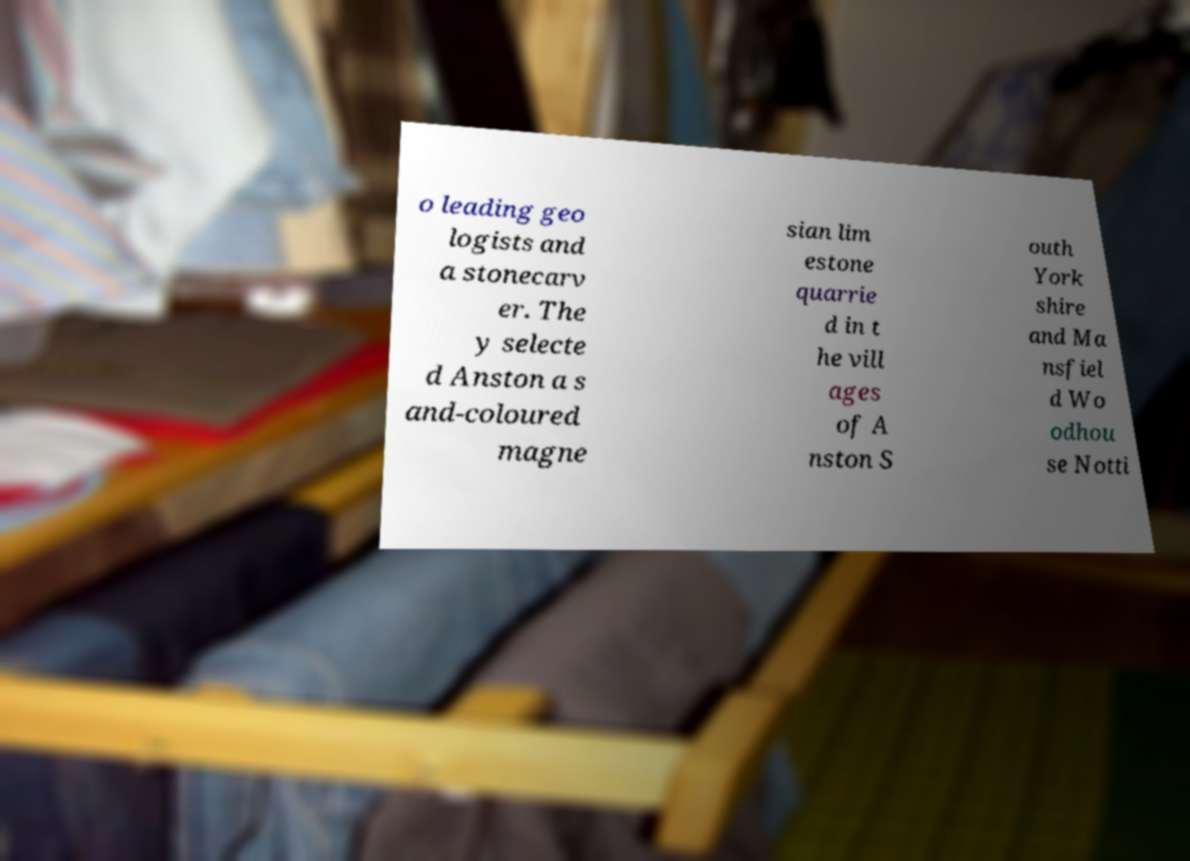Can you accurately transcribe the text from the provided image for me? o leading geo logists and a stonecarv er. The y selecte d Anston a s and-coloured magne sian lim estone quarrie d in t he vill ages of A nston S outh York shire and Ma nsfiel d Wo odhou se Notti 